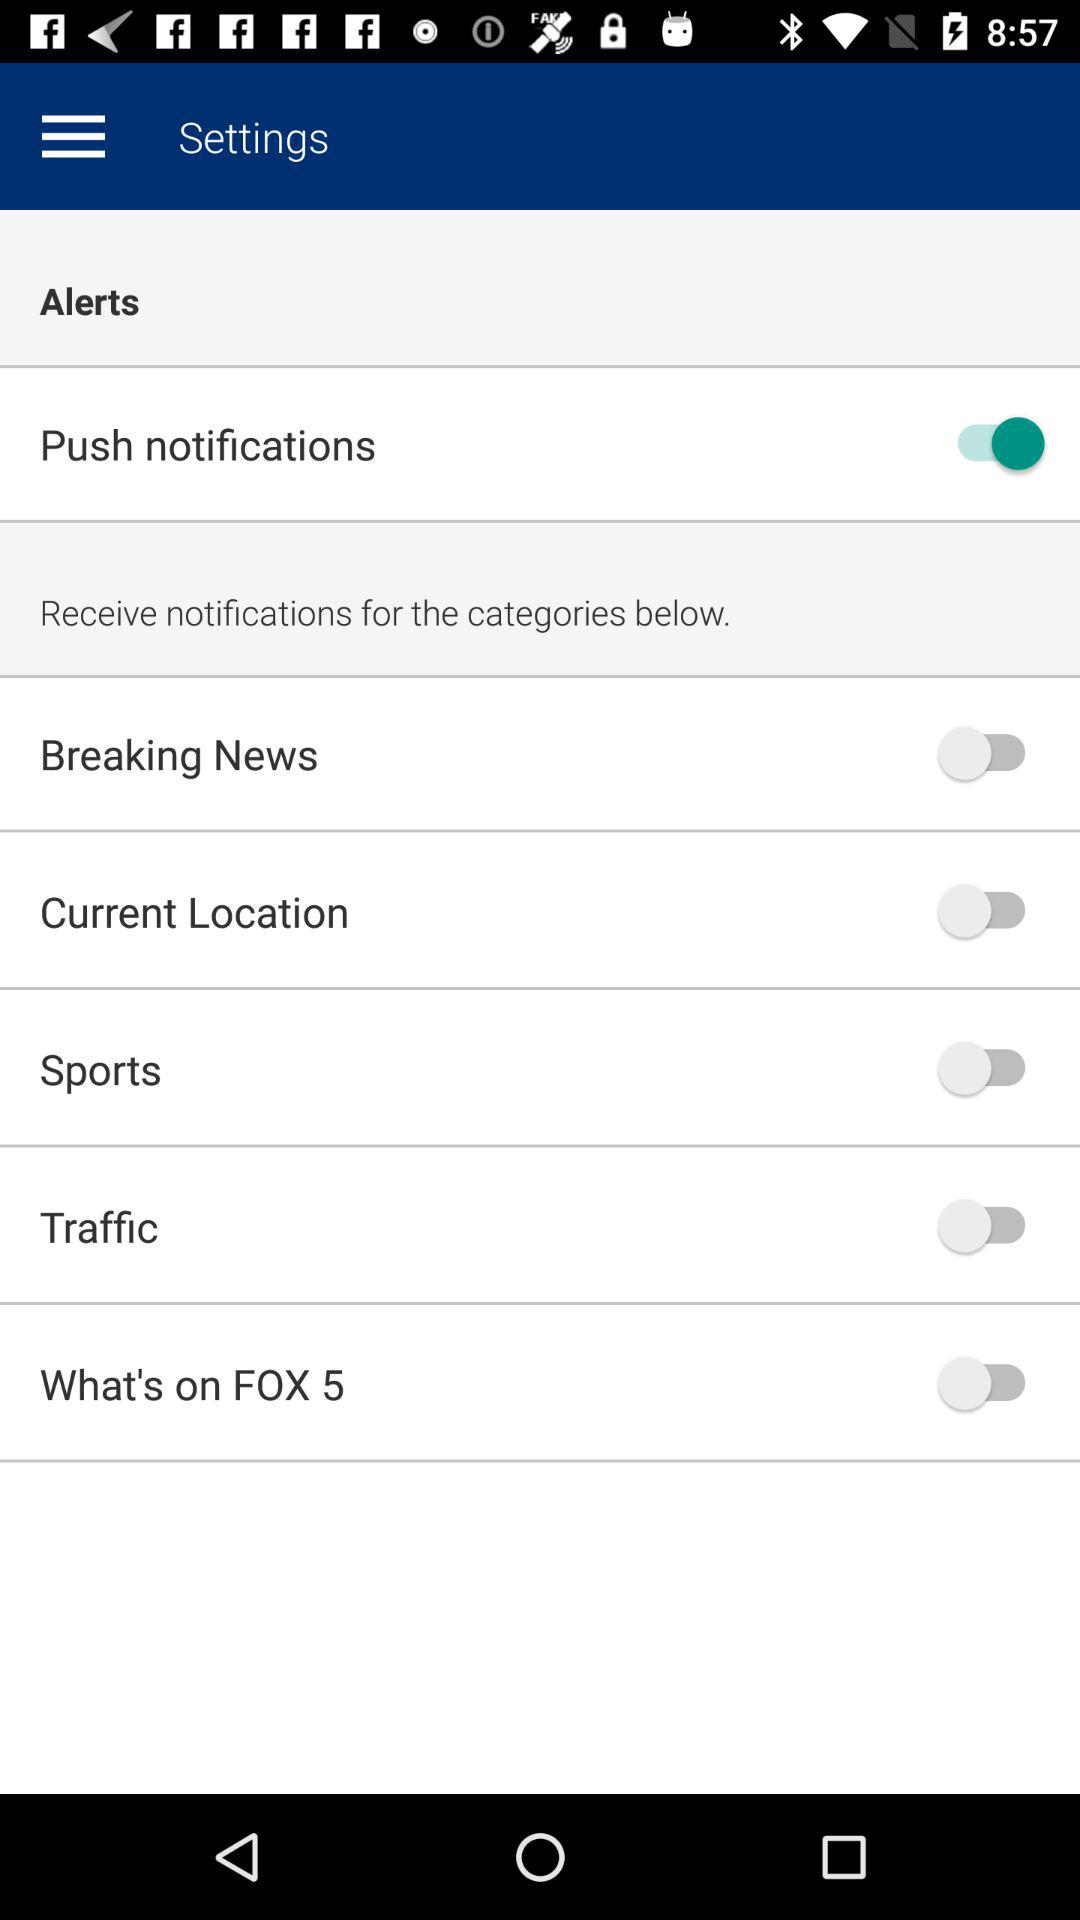What is the status of the "Traffic" alert? The status is "off". 